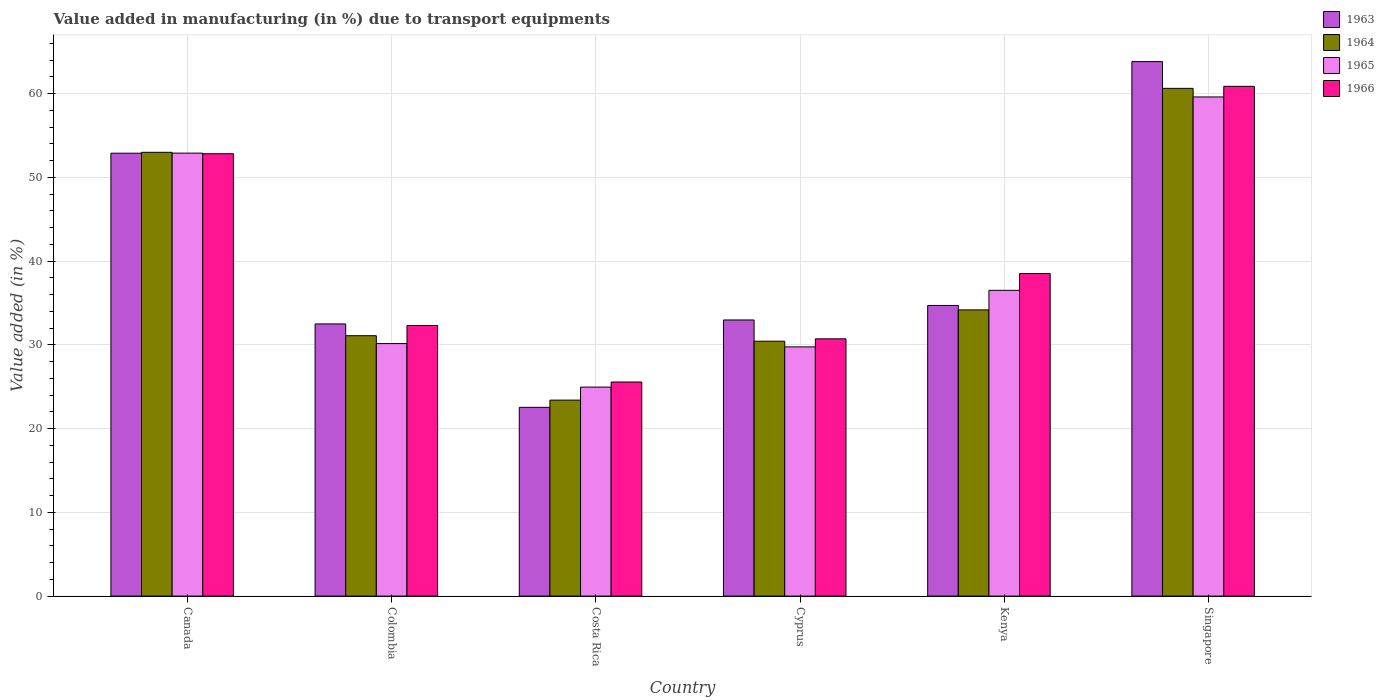Are the number of bars per tick equal to the number of legend labels?
Offer a very short reply. Yes. How many bars are there on the 3rd tick from the left?
Your answer should be compact. 4. What is the percentage of value added in manufacturing due to transport equipments in 1965 in Singapore?
Provide a short and direct response. 59.59. Across all countries, what is the maximum percentage of value added in manufacturing due to transport equipments in 1963?
Keep it short and to the point. 63.81. Across all countries, what is the minimum percentage of value added in manufacturing due to transport equipments in 1965?
Your answer should be very brief. 24.95. In which country was the percentage of value added in manufacturing due to transport equipments in 1963 maximum?
Ensure brevity in your answer.  Singapore. What is the total percentage of value added in manufacturing due to transport equipments in 1964 in the graph?
Keep it short and to the point. 232.68. What is the difference between the percentage of value added in manufacturing due to transport equipments in 1965 in Colombia and that in Kenya?
Your answer should be very brief. -6.36. What is the difference between the percentage of value added in manufacturing due to transport equipments in 1964 in Canada and the percentage of value added in manufacturing due to transport equipments in 1963 in Colombia?
Make the answer very short. 20.49. What is the average percentage of value added in manufacturing due to transport equipments in 1965 per country?
Provide a succinct answer. 38.97. What is the difference between the percentage of value added in manufacturing due to transport equipments of/in 1963 and percentage of value added in manufacturing due to transport equipments of/in 1964 in Singapore?
Ensure brevity in your answer.  3.19. In how many countries, is the percentage of value added in manufacturing due to transport equipments in 1965 greater than 6 %?
Provide a short and direct response. 6. What is the ratio of the percentage of value added in manufacturing due to transport equipments in 1965 in Cyprus to that in Singapore?
Make the answer very short. 0.5. Is the difference between the percentage of value added in manufacturing due to transport equipments in 1963 in Colombia and Kenya greater than the difference between the percentage of value added in manufacturing due to transport equipments in 1964 in Colombia and Kenya?
Your answer should be compact. Yes. What is the difference between the highest and the second highest percentage of value added in manufacturing due to transport equipments in 1963?
Your answer should be compact. -18.17. What is the difference between the highest and the lowest percentage of value added in manufacturing due to transport equipments in 1965?
Make the answer very short. 34.64. Is the sum of the percentage of value added in manufacturing due to transport equipments in 1965 in Costa Rica and Kenya greater than the maximum percentage of value added in manufacturing due to transport equipments in 1963 across all countries?
Offer a very short reply. No. Is it the case that in every country, the sum of the percentage of value added in manufacturing due to transport equipments in 1966 and percentage of value added in manufacturing due to transport equipments in 1963 is greater than the sum of percentage of value added in manufacturing due to transport equipments in 1964 and percentage of value added in manufacturing due to transport equipments in 1965?
Your answer should be very brief. No. What does the 3rd bar from the left in Kenya represents?
Offer a terse response. 1965. What does the 3rd bar from the right in Canada represents?
Provide a short and direct response. 1964. How many bars are there?
Your answer should be very brief. 24. How many countries are there in the graph?
Ensure brevity in your answer.  6. What is the difference between two consecutive major ticks on the Y-axis?
Keep it short and to the point. 10. Are the values on the major ticks of Y-axis written in scientific E-notation?
Give a very brief answer. No. Does the graph contain grids?
Give a very brief answer. Yes. Where does the legend appear in the graph?
Your response must be concise. Top right. How are the legend labels stacked?
Your answer should be compact. Vertical. What is the title of the graph?
Provide a short and direct response. Value added in manufacturing (in %) due to transport equipments. What is the label or title of the Y-axis?
Keep it short and to the point. Value added (in %). What is the Value added (in %) of 1963 in Canada?
Your response must be concise. 52.87. What is the Value added (in %) in 1964 in Canada?
Keep it short and to the point. 52.98. What is the Value added (in %) of 1965 in Canada?
Offer a terse response. 52.89. What is the Value added (in %) of 1966 in Canada?
Offer a terse response. 52.81. What is the Value added (in %) in 1963 in Colombia?
Keep it short and to the point. 32.49. What is the Value added (in %) of 1964 in Colombia?
Provide a short and direct response. 31.09. What is the Value added (in %) of 1965 in Colombia?
Provide a succinct answer. 30.15. What is the Value added (in %) in 1966 in Colombia?
Ensure brevity in your answer.  32.3. What is the Value added (in %) in 1963 in Costa Rica?
Provide a short and direct response. 22.53. What is the Value added (in %) of 1964 in Costa Rica?
Ensure brevity in your answer.  23.4. What is the Value added (in %) in 1965 in Costa Rica?
Your response must be concise. 24.95. What is the Value added (in %) of 1966 in Costa Rica?
Your answer should be compact. 25.56. What is the Value added (in %) of 1963 in Cyprus?
Provide a short and direct response. 32.97. What is the Value added (in %) in 1964 in Cyprus?
Your answer should be very brief. 30.43. What is the Value added (in %) of 1965 in Cyprus?
Your answer should be compact. 29.75. What is the Value added (in %) of 1966 in Cyprus?
Provide a succinct answer. 30.72. What is the Value added (in %) in 1963 in Kenya?
Offer a very short reply. 34.7. What is the Value added (in %) in 1964 in Kenya?
Offer a very short reply. 34.17. What is the Value added (in %) in 1965 in Kenya?
Give a very brief answer. 36.5. What is the Value added (in %) of 1966 in Kenya?
Provide a succinct answer. 38.51. What is the Value added (in %) in 1963 in Singapore?
Provide a short and direct response. 63.81. What is the Value added (in %) of 1964 in Singapore?
Offer a very short reply. 60.62. What is the Value added (in %) in 1965 in Singapore?
Give a very brief answer. 59.59. What is the Value added (in %) of 1966 in Singapore?
Keep it short and to the point. 60.86. Across all countries, what is the maximum Value added (in %) in 1963?
Your answer should be compact. 63.81. Across all countries, what is the maximum Value added (in %) of 1964?
Ensure brevity in your answer.  60.62. Across all countries, what is the maximum Value added (in %) in 1965?
Keep it short and to the point. 59.59. Across all countries, what is the maximum Value added (in %) of 1966?
Provide a succinct answer. 60.86. Across all countries, what is the minimum Value added (in %) in 1963?
Provide a succinct answer. 22.53. Across all countries, what is the minimum Value added (in %) of 1964?
Provide a succinct answer. 23.4. Across all countries, what is the minimum Value added (in %) in 1965?
Provide a succinct answer. 24.95. Across all countries, what is the minimum Value added (in %) of 1966?
Your answer should be compact. 25.56. What is the total Value added (in %) of 1963 in the graph?
Keep it short and to the point. 239.38. What is the total Value added (in %) of 1964 in the graph?
Offer a very short reply. 232.68. What is the total Value added (in %) of 1965 in the graph?
Ensure brevity in your answer.  233.83. What is the total Value added (in %) of 1966 in the graph?
Give a very brief answer. 240.76. What is the difference between the Value added (in %) in 1963 in Canada and that in Colombia?
Provide a succinct answer. 20.38. What is the difference between the Value added (in %) in 1964 in Canada and that in Colombia?
Your answer should be compact. 21.9. What is the difference between the Value added (in %) of 1965 in Canada and that in Colombia?
Offer a very short reply. 22.74. What is the difference between the Value added (in %) in 1966 in Canada and that in Colombia?
Give a very brief answer. 20.51. What is the difference between the Value added (in %) in 1963 in Canada and that in Costa Rica?
Offer a very short reply. 30.34. What is the difference between the Value added (in %) in 1964 in Canada and that in Costa Rica?
Offer a terse response. 29.59. What is the difference between the Value added (in %) of 1965 in Canada and that in Costa Rica?
Give a very brief answer. 27.93. What is the difference between the Value added (in %) in 1966 in Canada and that in Costa Rica?
Your answer should be very brief. 27.25. What is the difference between the Value added (in %) in 1963 in Canada and that in Cyprus?
Offer a very short reply. 19.91. What is the difference between the Value added (in %) of 1964 in Canada and that in Cyprus?
Keep it short and to the point. 22.55. What is the difference between the Value added (in %) in 1965 in Canada and that in Cyprus?
Keep it short and to the point. 23.13. What is the difference between the Value added (in %) in 1966 in Canada and that in Cyprus?
Your answer should be very brief. 22.1. What is the difference between the Value added (in %) in 1963 in Canada and that in Kenya?
Offer a very short reply. 18.17. What is the difference between the Value added (in %) of 1964 in Canada and that in Kenya?
Make the answer very short. 18.81. What is the difference between the Value added (in %) of 1965 in Canada and that in Kenya?
Ensure brevity in your answer.  16.38. What is the difference between the Value added (in %) of 1966 in Canada and that in Kenya?
Ensure brevity in your answer.  14.3. What is the difference between the Value added (in %) of 1963 in Canada and that in Singapore?
Offer a terse response. -10.94. What is the difference between the Value added (in %) of 1964 in Canada and that in Singapore?
Ensure brevity in your answer.  -7.63. What is the difference between the Value added (in %) of 1965 in Canada and that in Singapore?
Provide a short and direct response. -6.71. What is the difference between the Value added (in %) of 1966 in Canada and that in Singapore?
Ensure brevity in your answer.  -8.05. What is the difference between the Value added (in %) of 1963 in Colombia and that in Costa Rica?
Keep it short and to the point. 9.96. What is the difference between the Value added (in %) in 1964 in Colombia and that in Costa Rica?
Keep it short and to the point. 7.69. What is the difference between the Value added (in %) of 1965 in Colombia and that in Costa Rica?
Give a very brief answer. 5.2. What is the difference between the Value added (in %) in 1966 in Colombia and that in Costa Rica?
Keep it short and to the point. 6.74. What is the difference between the Value added (in %) in 1963 in Colombia and that in Cyprus?
Make the answer very short. -0.47. What is the difference between the Value added (in %) in 1964 in Colombia and that in Cyprus?
Offer a very short reply. 0.66. What is the difference between the Value added (in %) in 1965 in Colombia and that in Cyprus?
Your response must be concise. 0.39. What is the difference between the Value added (in %) of 1966 in Colombia and that in Cyprus?
Provide a succinct answer. 1.59. What is the difference between the Value added (in %) of 1963 in Colombia and that in Kenya?
Provide a short and direct response. -2.21. What is the difference between the Value added (in %) of 1964 in Colombia and that in Kenya?
Ensure brevity in your answer.  -3.08. What is the difference between the Value added (in %) of 1965 in Colombia and that in Kenya?
Provide a succinct answer. -6.36. What is the difference between the Value added (in %) of 1966 in Colombia and that in Kenya?
Your answer should be compact. -6.2. What is the difference between the Value added (in %) in 1963 in Colombia and that in Singapore?
Ensure brevity in your answer.  -31.32. What is the difference between the Value added (in %) of 1964 in Colombia and that in Singapore?
Offer a very short reply. -29.53. What is the difference between the Value added (in %) in 1965 in Colombia and that in Singapore?
Your response must be concise. -29.45. What is the difference between the Value added (in %) in 1966 in Colombia and that in Singapore?
Give a very brief answer. -28.56. What is the difference between the Value added (in %) of 1963 in Costa Rica and that in Cyprus?
Make the answer very short. -10.43. What is the difference between the Value added (in %) in 1964 in Costa Rica and that in Cyprus?
Give a very brief answer. -7.03. What is the difference between the Value added (in %) of 1965 in Costa Rica and that in Cyprus?
Offer a terse response. -4.8. What is the difference between the Value added (in %) in 1966 in Costa Rica and that in Cyprus?
Offer a very short reply. -5.16. What is the difference between the Value added (in %) of 1963 in Costa Rica and that in Kenya?
Your response must be concise. -12.17. What is the difference between the Value added (in %) in 1964 in Costa Rica and that in Kenya?
Offer a terse response. -10.77. What is the difference between the Value added (in %) of 1965 in Costa Rica and that in Kenya?
Offer a terse response. -11.55. What is the difference between the Value added (in %) in 1966 in Costa Rica and that in Kenya?
Your response must be concise. -12.95. What is the difference between the Value added (in %) of 1963 in Costa Rica and that in Singapore?
Give a very brief answer. -41.28. What is the difference between the Value added (in %) of 1964 in Costa Rica and that in Singapore?
Your response must be concise. -37.22. What is the difference between the Value added (in %) of 1965 in Costa Rica and that in Singapore?
Ensure brevity in your answer.  -34.64. What is the difference between the Value added (in %) of 1966 in Costa Rica and that in Singapore?
Offer a very short reply. -35.3. What is the difference between the Value added (in %) of 1963 in Cyprus and that in Kenya?
Your answer should be very brief. -1.73. What is the difference between the Value added (in %) in 1964 in Cyprus and that in Kenya?
Your answer should be very brief. -3.74. What is the difference between the Value added (in %) of 1965 in Cyprus and that in Kenya?
Your response must be concise. -6.75. What is the difference between the Value added (in %) in 1966 in Cyprus and that in Kenya?
Your answer should be very brief. -7.79. What is the difference between the Value added (in %) in 1963 in Cyprus and that in Singapore?
Provide a short and direct response. -30.84. What is the difference between the Value added (in %) of 1964 in Cyprus and that in Singapore?
Offer a terse response. -30.19. What is the difference between the Value added (in %) in 1965 in Cyprus and that in Singapore?
Provide a succinct answer. -29.84. What is the difference between the Value added (in %) in 1966 in Cyprus and that in Singapore?
Your answer should be very brief. -30.14. What is the difference between the Value added (in %) in 1963 in Kenya and that in Singapore?
Provide a short and direct response. -29.11. What is the difference between the Value added (in %) of 1964 in Kenya and that in Singapore?
Give a very brief answer. -26.45. What is the difference between the Value added (in %) in 1965 in Kenya and that in Singapore?
Make the answer very short. -23.09. What is the difference between the Value added (in %) in 1966 in Kenya and that in Singapore?
Offer a very short reply. -22.35. What is the difference between the Value added (in %) of 1963 in Canada and the Value added (in %) of 1964 in Colombia?
Ensure brevity in your answer.  21.79. What is the difference between the Value added (in %) of 1963 in Canada and the Value added (in %) of 1965 in Colombia?
Keep it short and to the point. 22.73. What is the difference between the Value added (in %) in 1963 in Canada and the Value added (in %) in 1966 in Colombia?
Offer a terse response. 20.57. What is the difference between the Value added (in %) in 1964 in Canada and the Value added (in %) in 1965 in Colombia?
Make the answer very short. 22.84. What is the difference between the Value added (in %) in 1964 in Canada and the Value added (in %) in 1966 in Colombia?
Offer a terse response. 20.68. What is the difference between the Value added (in %) of 1965 in Canada and the Value added (in %) of 1966 in Colombia?
Provide a short and direct response. 20.58. What is the difference between the Value added (in %) in 1963 in Canada and the Value added (in %) in 1964 in Costa Rica?
Offer a terse response. 29.48. What is the difference between the Value added (in %) of 1963 in Canada and the Value added (in %) of 1965 in Costa Rica?
Your answer should be compact. 27.92. What is the difference between the Value added (in %) of 1963 in Canada and the Value added (in %) of 1966 in Costa Rica?
Your answer should be compact. 27.31. What is the difference between the Value added (in %) of 1964 in Canada and the Value added (in %) of 1965 in Costa Rica?
Your response must be concise. 28.03. What is the difference between the Value added (in %) of 1964 in Canada and the Value added (in %) of 1966 in Costa Rica?
Provide a succinct answer. 27.42. What is the difference between the Value added (in %) in 1965 in Canada and the Value added (in %) in 1966 in Costa Rica?
Offer a very short reply. 27.33. What is the difference between the Value added (in %) in 1963 in Canada and the Value added (in %) in 1964 in Cyprus?
Give a very brief answer. 22.44. What is the difference between the Value added (in %) of 1963 in Canada and the Value added (in %) of 1965 in Cyprus?
Keep it short and to the point. 23.12. What is the difference between the Value added (in %) of 1963 in Canada and the Value added (in %) of 1966 in Cyprus?
Provide a short and direct response. 22.16. What is the difference between the Value added (in %) of 1964 in Canada and the Value added (in %) of 1965 in Cyprus?
Provide a succinct answer. 23.23. What is the difference between the Value added (in %) in 1964 in Canada and the Value added (in %) in 1966 in Cyprus?
Give a very brief answer. 22.27. What is the difference between the Value added (in %) in 1965 in Canada and the Value added (in %) in 1966 in Cyprus?
Your answer should be very brief. 22.17. What is the difference between the Value added (in %) in 1963 in Canada and the Value added (in %) in 1964 in Kenya?
Give a very brief answer. 18.7. What is the difference between the Value added (in %) of 1963 in Canada and the Value added (in %) of 1965 in Kenya?
Your answer should be very brief. 16.37. What is the difference between the Value added (in %) of 1963 in Canada and the Value added (in %) of 1966 in Kenya?
Provide a short and direct response. 14.37. What is the difference between the Value added (in %) in 1964 in Canada and the Value added (in %) in 1965 in Kenya?
Make the answer very short. 16.48. What is the difference between the Value added (in %) of 1964 in Canada and the Value added (in %) of 1966 in Kenya?
Ensure brevity in your answer.  14.47. What is the difference between the Value added (in %) of 1965 in Canada and the Value added (in %) of 1966 in Kenya?
Ensure brevity in your answer.  14.38. What is the difference between the Value added (in %) in 1963 in Canada and the Value added (in %) in 1964 in Singapore?
Keep it short and to the point. -7.74. What is the difference between the Value added (in %) in 1963 in Canada and the Value added (in %) in 1965 in Singapore?
Provide a short and direct response. -6.72. What is the difference between the Value added (in %) in 1963 in Canada and the Value added (in %) in 1966 in Singapore?
Your response must be concise. -7.99. What is the difference between the Value added (in %) in 1964 in Canada and the Value added (in %) in 1965 in Singapore?
Offer a terse response. -6.61. What is the difference between the Value added (in %) in 1964 in Canada and the Value added (in %) in 1966 in Singapore?
Your response must be concise. -7.88. What is the difference between the Value added (in %) in 1965 in Canada and the Value added (in %) in 1966 in Singapore?
Your response must be concise. -7.97. What is the difference between the Value added (in %) of 1963 in Colombia and the Value added (in %) of 1964 in Costa Rica?
Provide a succinct answer. 9.1. What is the difference between the Value added (in %) of 1963 in Colombia and the Value added (in %) of 1965 in Costa Rica?
Offer a terse response. 7.54. What is the difference between the Value added (in %) in 1963 in Colombia and the Value added (in %) in 1966 in Costa Rica?
Your answer should be compact. 6.93. What is the difference between the Value added (in %) of 1964 in Colombia and the Value added (in %) of 1965 in Costa Rica?
Make the answer very short. 6.14. What is the difference between the Value added (in %) of 1964 in Colombia and the Value added (in %) of 1966 in Costa Rica?
Ensure brevity in your answer.  5.53. What is the difference between the Value added (in %) in 1965 in Colombia and the Value added (in %) in 1966 in Costa Rica?
Your answer should be compact. 4.59. What is the difference between the Value added (in %) of 1963 in Colombia and the Value added (in %) of 1964 in Cyprus?
Ensure brevity in your answer.  2.06. What is the difference between the Value added (in %) of 1963 in Colombia and the Value added (in %) of 1965 in Cyprus?
Provide a short and direct response. 2.74. What is the difference between the Value added (in %) of 1963 in Colombia and the Value added (in %) of 1966 in Cyprus?
Make the answer very short. 1.78. What is the difference between the Value added (in %) in 1964 in Colombia and the Value added (in %) in 1965 in Cyprus?
Make the answer very short. 1.33. What is the difference between the Value added (in %) in 1964 in Colombia and the Value added (in %) in 1966 in Cyprus?
Offer a terse response. 0.37. What is the difference between the Value added (in %) in 1965 in Colombia and the Value added (in %) in 1966 in Cyprus?
Ensure brevity in your answer.  -0.57. What is the difference between the Value added (in %) in 1963 in Colombia and the Value added (in %) in 1964 in Kenya?
Ensure brevity in your answer.  -1.68. What is the difference between the Value added (in %) of 1963 in Colombia and the Value added (in %) of 1965 in Kenya?
Your answer should be compact. -4.01. What is the difference between the Value added (in %) of 1963 in Colombia and the Value added (in %) of 1966 in Kenya?
Make the answer very short. -6.01. What is the difference between the Value added (in %) in 1964 in Colombia and the Value added (in %) in 1965 in Kenya?
Your response must be concise. -5.42. What is the difference between the Value added (in %) in 1964 in Colombia and the Value added (in %) in 1966 in Kenya?
Make the answer very short. -7.42. What is the difference between the Value added (in %) of 1965 in Colombia and the Value added (in %) of 1966 in Kenya?
Your answer should be very brief. -8.36. What is the difference between the Value added (in %) of 1963 in Colombia and the Value added (in %) of 1964 in Singapore?
Your response must be concise. -28.12. What is the difference between the Value added (in %) in 1963 in Colombia and the Value added (in %) in 1965 in Singapore?
Your answer should be compact. -27.1. What is the difference between the Value added (in %) in 1963 in Colombia and the Value added (in %) in 1966 in Singapore?
Provide a short and direct response. -28.37. What is the difference between the Value added (in %) in 1964 in Colombia and the Value added (in %) in 1965 in Singapore?
Make the answer very short. -28.51. What is the difference between the Value added (in %) in 1964 in Colombia and the Value added (in %) in 1966 in Singapore?
Keep it short and to the point. -29.77. What is the difference between the Value added (in %) of 1965 in Colombia and the Value added (in %) of 1966 in Singapore?
Make the answer very short. -30.71. What is the difference between the Value added (in %) of 1963 in Costa Rica and the Value added (in %) of 1964 in Cyprus?
Offer a terse response. -7.9. What is the difference between the Value added (in %) of 1963 in Costa Rica and the Value added (in %) of 1965 in Cyprus?
Your response must be concise. -7.22. What is the difference between the Value added (in %) in 1963 in Costa Rica and the Value added (in %) in 1966 in Cyprus?
Give a very brief answer. -8.18. What is the difference between the Value added (in %) of 1964 in Costa Rica and the Value added (in %) of 1965 in Cyprus?
Keep it short and to the point. -6.36. What is the difference between the Value added (in %) of 1964 in Costa Rica and the Value added (in %) of 1966 in Cyprus?
Provide a short and direct response. -7.32. What is the difference between the Value added (in %) in 1965 in Costa Rica and the Value added (in %) in 1966 in Cyprus?
Ensure brevity in your answer.  -5.77. What is the difference between the Value added (in %) in 1963 in Costa Rica and the Value added (in %) in 1964 in Kenya?
Your answer should be compact. -11.64. What is the difference between the Value added (in %) in 1963 in Costa Rica and the Value added (in %) in 1965 in Kenya?
Provide a short and direct response. -13.97. What is the difference between the Value added (in %) of 1963 in Costa Rica and the Value added (in %) of 1966 in Kenya?
Your answer should be compact. -15.97. What is the difference between the Value added (in %) in 1964 in Costa Rica and the Value added (in %) in 1965 in Kenya?
Your response must be concise. -13.11. What is the difference between the Value added (in %) in 1964 in Costa Rica and the Value added (in %) in 1966 in Kenya?
Your response must be concise. -15.11. What is the difference between the Value added (in %) in 1965 in Costa Rica and the Value added (in %) in 1966 in Kenya?
Your answer should be compact. -13.56. What is the difference between the Value added (in %) in 1963 in Costa Rica and the Value added (in %) in 1964 in Singapore?
Your answer should be compact. -38.08. What is the difference between the Value added (in %) of 1963 in Costa Rica and the Value added (in %) of 1965 in Singapore?
Give a very brief answer. -37.06. What is the difference between the Value added (in %) of 1963 in Costa Rica and the Value added (in %) of 1966 in Singapore?
Give a very brief answer. -38.33. What is the difference between the Value added (in %) in 1964 in Costa Rica and the Value added (in %) in 1965 in Singapore?
Make the answer very short. -36.19. What is the difference between the Value added (in %) in 1964 in Costa Rica and the Value added (in %) in 1966 in Singapore?
Give a very brief answer. -37.46. What is the difference between the Value added (in %) of 1965 in Costa Rica and the Value added (in %) of 1966 in Singapore?
Offer a terse response. -35.91. What is the difference between the Value added (in %) of 1963 in Cyprus and the Value added (in %) of 1964 in Kenya?
Your response must be concise. -1.2. What is the difference between the Value added (in %) of 1963 in Cyprus and the Value added (in %) of 1965 in Kenya?
Offer a very short reply. -3.54. What is the difference between the Value added (in %) in 1963 in Cyprus and the Value added (in %) in 1966 in Kenya?
Keep it short and to the point. -5.54. What is the difference between the Value added (in %) in 1964 in Cyprus and the Value added (in %) in 1965 in Kenya?
Give a very brief answer. -6.07. What is the difference between the Value added (in %) in 1964 in Cyprus and the Value added (in %) in 1966 in Kenya?
Your answer should be very brief. -8.08. What is the difference between the Value added (in %) in 1965 in Cyprus and the Value added (in %) in 1966 in Kenya?
Offer a terse response. -8.75. What is the difference between the Value added (in %) of 1963 in Cyprus and the Value added (in %) of 1964 in Singapore?
Your answer should be compact. -27.65. What is the difference between the Value added (in %) of 1963 in Cyprus and the Value added (in %) of 1965 in Singapore?
Your answer should be very brief. -26.62. What is the difference between the Value added (in %) in 1963 in Cyprus and the Value added (in %) in 1966 in Singapore?
Offer a very short reply. -27.89. What is the difference between the Value added (in %) in 1964 in Cyprus and the Value added (in %) in 1965 in Singapore?
Your answer should be very brief. -29.16. What is the difference between the Value added (in %) in 1964 in Cyprus and the Value added (in %) in 1966 in Singapore?
Your answer should be very brief. -30.43. What is the difference between the Value added (in %) of 1965 in Cyprus and the Value added (in %) of 1966 in Singapore?
Your answer should be very brief. -31.11. What is the difference between the Value added (in %) in 1963 in Kenya and the Value added (in %) in 1964 in Singapore?
Your answer should be compact. -25.92. What is the difference between the Value added (in %) in 1963 in Kenya and the Value added (in %) in 1965 in Singapore?
Provide a succinct answer. -24.89. What is the difference between the Value added (in %) in 1963 in Kenya and the Value added (in %) in 1966 in Singapore?
Your response must be concise. -26.16. What is the difference between the Value added (in %) of 1964 in Kenya and the Value added (in %) of 1965 in Singapore?
Ensure brevity in your answer.  -25.42. What is the difference between the Value added (in %) in 1964 in Kenya and the Value added (in %) in 1966 in Singapore?
Your response must be concise. -26.69. What is the difference between the Value added (in %) of 1965 in Kenya and the Value added (in %) of 1966 in Singapore?
Give a very brief answer. -24.36. What is the average Value added (in %) in 1963 per country?
Offer a very short reply. 39.9. What is the average Value added (in %) of 1964 per country?
Make the answer very short. 38.78. What is the average Value added (in %) in 1965 per country?
Make the answer very short. 38.97. What is the average Value added (in %) of 1966 per country?
Make the answer very short. 40.13. What is the difference between the Value added (in %) in 1963 and Value added (in %) in 1964 in Canada?
Give a very brief answer. -0.11. What is the difference between the Value added (in %) of 1963 and Value added (in %) of 1965 in Canada?
Give a very brief answer. -0.01. What is the difference between the Value added (in %) of 1963 and Value added (in %) of 1966 in Canada?
Keep it short and to the point. 0.06. What is the difference between the Value added (in %) of 1964 and Value added (in %) of 1965 in Canada?
Offer a terse response. 0.1. What is the difference between the Value added (in %) in 1964 and Value added (in %) in 1966 in Canada?
Your answer should be compact. 0.17. What is the difference between the Value added (in %) in 1965 and Value added (in %) in 1966 in Canada?
Your response must be concise. 0.07. What is the difference between the Value added (in %) in 1963 and Value added (in %) in 1964 in Colombia?
Your response must be concise. 1.41. What is the difference between the Value added (in %) of 1963 and Value added (in %) of 1965 in Colombia?
Make the answer very short. 2.35. What is the difference between the Value added (in %) in 1963 and Value added (in %) in 1966 in Colombia?
Provide a short and direct response. 0.19. What is the difference between the Value added (in %) in 1964 and Value added (in %) in 1965 in Colombia?
Offer a very short reply. 0.94. What is the difference between the Value added (in %) in 1964 and Value added (in %) in 1966 in Colombia?
Offer a very short reply. -1.22. What is the difference between the Value added (in %) in 1965 and Value added (in %) in 1966 in Colombia?
Ensure brevity in your answer.  -2.16. What is the difference between the Value added (in %) of 1963 and Value added (in %) of 1964 in Costa Rica?
Your response must be concise. -0.86. What is the difference between the Value added (in %) of 1963 and Value added (in %) of 1965 in Costa Rica?
Your answer should be very brief. -2.42. What is the difference between the Value added (in %) of 1963 and Value added (in %) of 1966 in Costa Rica?
Your response must be concise. -3.03. What is the difference between the Value added (in %) of 1964 and Value added (in %) of 1965 in Costa Rica?
Make the answer very short. -1.55. What is the difference between the Value added (in %) in 1964 and Value added (in %) in 1966 in Costa Rica?
Your answer should be very brief. -2.16. What is the difference between the Value added (in %) in 1965 and Value added (in %) in 1966 in Costa Rica?
Your answer should be very brief. -0.61. What is the difference between the Value added (in %) of 1963 and Value added (in %) of 1964 in Cyprus?
Offer a terse response. 2.54. What is the difference between the Value added (in %) in 1963 and Value added (in %) in 1965 in Cyprus?
Ensure brevity in your answer.  3.21. What is the difference between the Value added (in %) in 1963 and Value added (in %) in 1966 in Cyprus?
Your answer should be compact. 2.25. What is the difference between the Value added (in %) of 1964 and Value added (in %) of 1965 in Cyprus?
Offer a terse response. 0.68. What is the difference between the Value added (in %) in 1964 and Value added (in %) in 1966 in Cyprus?
Offer a terse response. -0.29. What is the difference between the Value added (in %) in 1965 and Value added (in %) in 1966 in Cyprus?
Provide a succinct answer. -0.96. What is the difference between the Value added (in %) of 1963 and Value added (in %) of 1964 in Kenya?
Your response must be concise. 0.53. What is the difference between the Value added (in %) of 1963 and Value added (in %) of 1965 in Kenya?
Your response must be concise. -1.8. What is the difference between the Value added (in %) of 1963 and Value added (in %) of 1966 in Kenya?
Offer a terse response. -3.81. What is the difference between the Value added (in %) of 1964 and Value added (in %) of 1965 in Kenya?
Ensure brevity in your answer.  -2.33. What is the difference between the Value added (in %) in 1964 and Value added (in %) in 1966 in Kenya?
Your answer should be compact. -4.34. What is the difference between the Value added (in %) of 1965 and Value added (in %) of 1966 in Kenya?
Offer a terse response. -2. What is the difference between the Value added (in %) of 1963 and Value added (in %) of 1964 in Singapore?
Ensure brevity in your answer.  3.19. What is the difference between the Value added (in %) of 1963 and Value added (in %) of 1965 in Singapore?
Offer a terse response. 4.22. What is the difference between the Value added (in %) in 1963 and Value added (in %) in 1966 in Singapore?
Give a very brief answer. 2.95. What is the difference between the Value added (in %) of 1964 and Value added (in %) of 1965 in Singapore?
Your answer should be compact. 1.03. What is the difference between the Value added (in %) in 1964 and Value added (in %) in 1966 in Singapore?
Make the answer very short. -0.24. What is the difference between the Value added (in %) in 1965 and Value added (in %) in 1966 in Singapore?
Give a very brief answer. -1.27. What is the ratio of the Value added (in %) in 1963 in Canada to that in Colombia?
Give a very brief answer. 1.63. What is the ratio of the Value added (in %) in 1964 in Canada to that in Colombia?
Ensure brevity in your answer.  1.7. What is the ratio of the Value added (in %) in 1965 in Canada to that in Colombia?
Give a very brief answer. 1.75. What is the ratio of the Value added (in %) of 1966 in Canada to that in Colombia?
Ensure brevity in your answer.  1.63. What is the ratio of the Value added (in %) in 1963 in Canada to that in Costa Rica?
Give a very brief answer. 2.35. What is the ratio of the Value added (in %) in 1964 in Canada to that in Costa Rica?
Provide a succinct answer. 2.26. What is the ratio of the Value added (in %) in 1965 in Canada to that in Costa Rica?
Offer a terse response. 2.12. What is the ratio of the Value added (in %) in 1966 in Canada to that in Costa Rica?
Your response must be concise. 2.07. What is the ratio of the Value added (in %) of 1963 in Canada to that in Cyprus?
Offer a terse response. 1.6. What is the ratio of the Value added (in %) of 1964 in Canada to that in Cyprus?
Your answer should be very brief. 1.74. What is the ratio of the Value added (in %) in 1965 in Canada to that in Cyprus?
Offer a very short reply. 1.78. What is the ratio of the Value added (in %) in 1966 in Canada to that in Cyprus?
Your answer should be very brief. 1.72. What is the ratio of the Value added (in %) of 1963 in Canada to that in Kenya?
Offer a terse response. 1.52. What is the ratio of the Value added (in %) in 1964 in Canada to that in Kenya?
Offer a very short reply. 1.55. What is the ratio of the Value added (in %) in 1965 in Canada to that in Kenya?
Provide a short and direct response. 1.45. What is the ratio of the Value added (in %) of 1966 in Canada to that in Kenya?
Give a very brief answer. 1.37. What is the ratio of the Value added (in %) of 1963 in Canada to that in Singapore?
Give a very brief answer. 0.83. What is the ratio of the Value added (in %) in 1964 in Canada to that in Singapore?
Offer a terse response. 0.87. What is the ratio of the Value added (in %) of 1965 in Canada to that in Singapore?
Your answer should be compact. 0.89. What is the ratio of the Value added (in %) in 1966 in Canada to that in Singapore?
Provide a short and direct response. 0.87. What is the ratio of the Value added (in %) in 1963 in Colombia to that in Costa Rica?
Your answer should be very brief. 1.44. What is the ratio of the Value added (in %) in 1964 in Colombia to that in Costa Rica?
Give a very brief answer. 1.33. What is the ratio of the Value added (in %) in 1965 in Colombia to that in Costa Rica?
Give a very brief answer. 1.21. What is the ratio of the Value added (in %) of 1966 in Colombia to that in Costa Rica?
Your answer should be compact. 1.26. What is the ratio of the Value added (in %) in 1963 in Colombia to that in Cyprus?
Provide a succinct answer. 0.99. What is the ratio of the Value added (in %) of 1964 in Colombia to that in Cyprus?
Offer a terse response. 1.02. What is the ratio of the Value added (in %) of 1965 in Colombia to that in Cyprus?
Provide a short and direct response. 1.01. What is the ratio of the Value added (in %) in 1966 in Colombia to that in Cyprus?
Your answer should be very brief. 1.05. What is the ratio of the Value added (in %) of 1963 in Colombia to that in Kenya?
Ensure brevity in your answer.  0.94. What is the ratio of the Value added (in %) of 1964 in Colombia to that in Kenya?
Your answer should be compact. 0.91. What is the ratio of the Value added (in %) in 1965 in Colombia to that in Kenya?
Keep it short and to the point. 0.83. What is the ratio of the Value added (in %) in 1966 in Colombia to that in Kenya?
Provide a short and direct response. 0.84. What is the ratio of the Value added (in %) of 1963 in Colombia to that in Singapore?
Offer a terse response. 0.51. What is the ratio of the Value added (in %) in 1964 in Colombia to that in Singapore?
Your answer should be compact. 0.51. What is the ratio of the Value added (in %) of 1965 in Colombia to that in Singapore?
Keep it short and to the point. 0.51. What is the ratio of the Value added (in %) in 1966 in Colombia to that in Singapore?
Your answer should be very brief. 0.53. What is the ratio of the Value added (in %) of 1963 in Costa Rica to that in Cyprus?
Your response must be concise. 0.68. What is the ratio of the Value added (in %) in 1964 in Costa Rica to that in Cyprus?
Offer a very short reply. 0.77. What is the ratio of the Value added (in %) in 1965 in Costa Rica to that in Cyprus?
Your response must be concise. 0.84. What is the ratio of the Value added (in %) in 1966 in Costa Rica to that in Cyprus?
Your answer should be compact. 0.83. What is the ratio of the Value added (in %) in 1963 in Costa Rica to that in Kenya?
Offer a very short reply. 0.65. What is the ratio of the Value added (in %) in 1964 in Costa Rica to that in Kenya?
Make the answer very short. 0.68. What is the ratio of the Value added (in %) in 1965 in Costa Rica to that in Kenya?
Offer a very short reply. 0.68. What is the ratio of the Value added (in %) of 1966 in Costa Rica to that in Kenya?
Provide a succinct answer. 0.66. What is the ratio of the Value added (in %) of 1963 in Costa Rica to that in Singapore?
Offer a very short reply. 0.35. What is the ratio of the Value added (in %) in 1964 in Costa Rica to that in Singapore?
Provide a succinct answer. 0.39. What is the ratio of the Value added (in %) in 1965 in Costa Rica to that in Singapore?
Offer a very short reply. 0.42. What is the ratio of the Value added (in %) in 1966 in Costa Rica to that in Singapore?
Your answer should be very brief. 0.42. What is the ratio of the Value added (in %) in 1963 in Cyprus to that in Kenya?
Your response must be concise. 0.95. What is the ratio of the Value added (in %) in 1964 in Cyprus to that in Kenya?
Offer a terse response. 0.89. What is the ratio of the Value added (in %) of 1965 in Cyprus to that in Kenya?
Make the answer very short. 0.82. What is the ratio of the Value added (in %) in 1966 in Cyprus to that in Kenya?
Provide a succinct answer. 0.8. What is the ratio of the Value added (in %) in 1963 in Cyprus to that in Singapore?
Your response must be concise. 0.52. What is the ratio of the Value added (in %) of 1964 in Cyprus to that in Singapore?
Give a very brief answer. 0.5. What is the ratio of the Value added (in %) in 1965 in Cyprus to that in Singapore?
Provide a short and direct response. 0.5. What is the ratio of the Value added (in %) in 1966 in Cyprus to that in Singapore?
Your answer should be very brief. 0.5. What is the ratio of the Value added (in %) of 1963 in Kenya to that in Singapore?
Keep it short and to the point. 0.54. What is the ratio of the Value added (in %) in 1964 in Kenya to that in Singapore?
Your response must be concise. 0.56. What is the ratio of the Value added (in %) of 1965 in Kenya to that in Singapore?
Make the answer very short. 0.61. What is the ratio of the Value added (in %) in 1966 in Kenya to that in Singapore?
Give a very brief answer. 0.63. What is the difference between the highest and the second highest Value added (in %) of 1963?
Keep it short and to the point. 10.94. What is the difference between the highest and the second highest Value added (in %) in 1964?
Provide a short and direct response. 7.63. What is the difference between the highest and the second highest Value added (in %) in 1965?
Your answer should be compact. 6.71. What is the difference between the highest and the second highest Value added (in %) of 1966?
Your answer should be compact. 8.05. What is the difference between the highest and the lowest Value added (in %) of 1963?
Your answer should be compact. 41.28. What is the difference between the highest and the lowest Value added (in %) in 1964?
Your answer should be compact. 37.22. What is the difference between the highest and the lowest Value added (in %) of 1965?
Offer a terse response. 34.64. What is the difference between the highest and the lowest Value added (in %) of 1966?
Your answer should be compact. 35.3. 